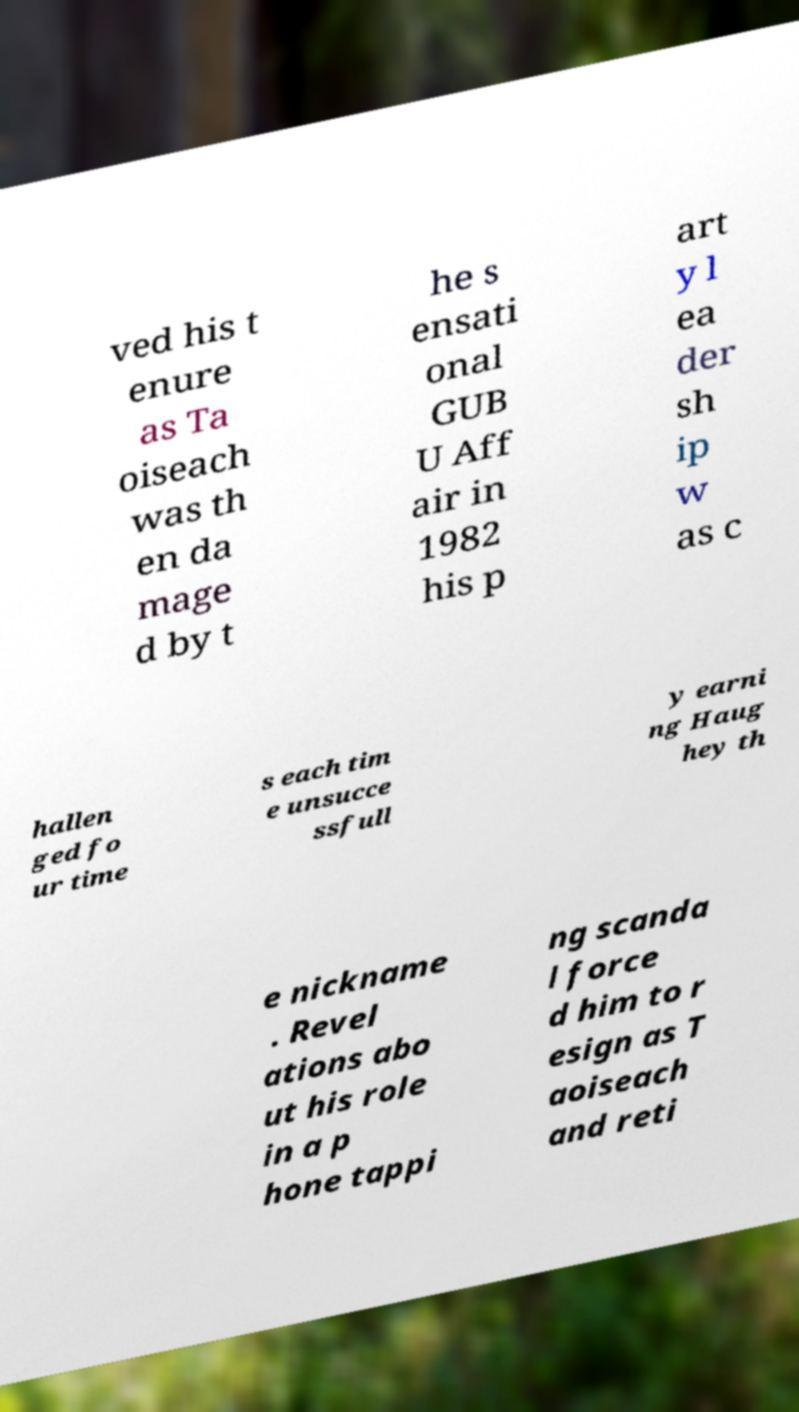For documentation purposes, I need the text within this image transcribed. Could you provide that? ved his t enure as Ta oiseach was th en da mage d by t he s ensati onal GUB U Aff air in 1982 his p art y l ea der sh ip w as c hallen ged fo ur time s each tim e unsucce ssfull y earni ng Haug hey th e nickname . Revel ations abo ut his role in a p hone tappi ng scanda l force d him to r esign as T aoiseach and reti 